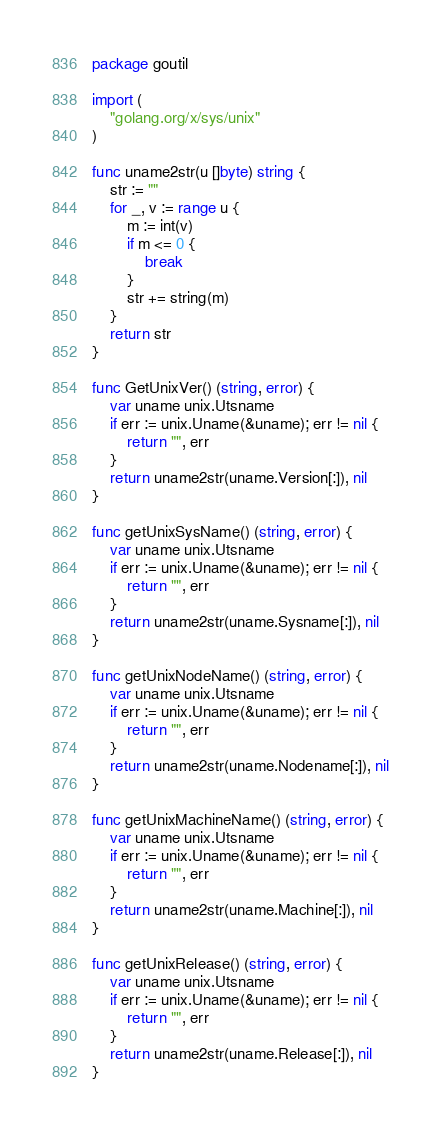Convert code to text. <code><loc_0><loc_0><loc_500><loc_500><_Go_>package goutil

import (
	"golang.org/x/sys/unix"
)

func uname2str(u []byte) string {
	str := ""
	for _, v := range u {
		m := int(v)
		if m <= 0 {
			break
		}
		str += string(m)
	}
	return str
}

func GetUnixVer() (string, error) {
	var uname unix.Utsname
	if err := unix.Uname(&uname); err != nil {
		return "", err
	}
	return uname2str(uname.Version[:]), nil
}

func getUnixSysName() (string, error) {
	var uname unix.Utsname
	if err := unix.Uname(&uname); err != nil {
		return "", err
	}
	return uname2str(uname.Sysname[:]), nil
}

func getUnixNodeName() (string, error) {
	var uname unix.Utsname
	if err := unix.Uname(&uname); err != nil {
		return "", err
	}
	return uname2str(uname.Nodename[:]), nil
}

func getUnixMachineName() (string, error) {
	var uname unix.Utsname
	if err := unix.Uname(&uname); err != nil {
		return "", err
	}
	return uname2str(uname.Machine[:]), nil
}

func getUnixRelease() (string, error) {
	var uname unix.Utsname
	if err := unix.Uname(&uname); err != nil {
		return "", err
	}
	return uname2str(uname.Release[:]), nil
}
</code> 